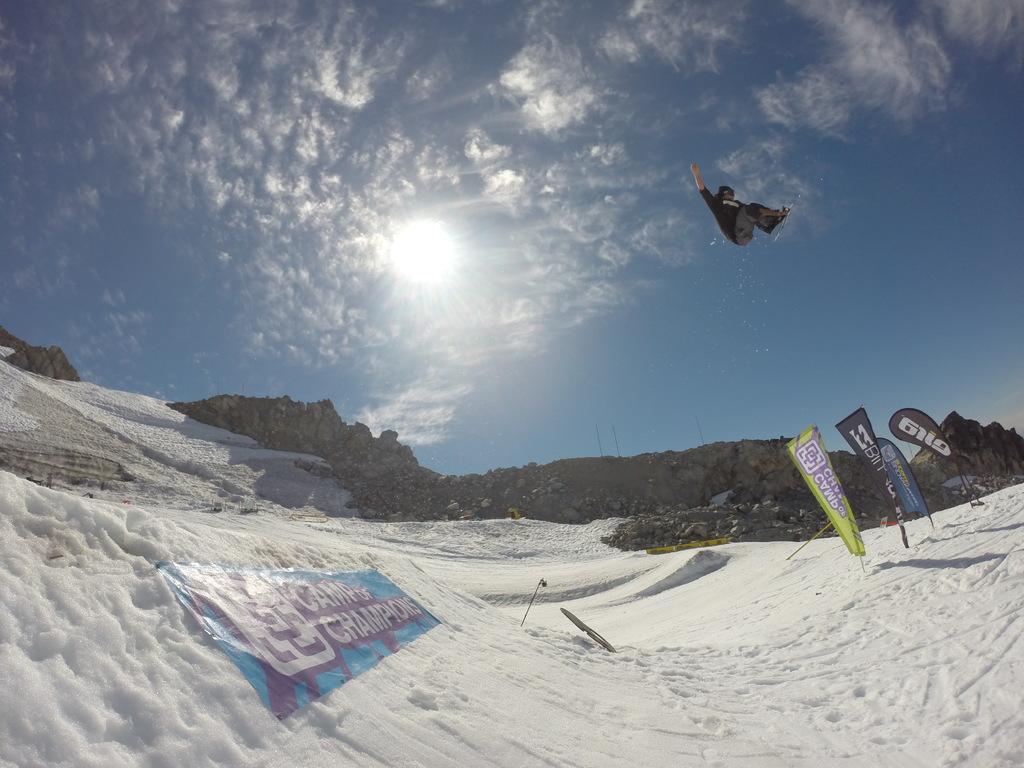Please provide a concise description of this image. In this picture I can see snow. I can see mountains. I can see clouds in the sky. 